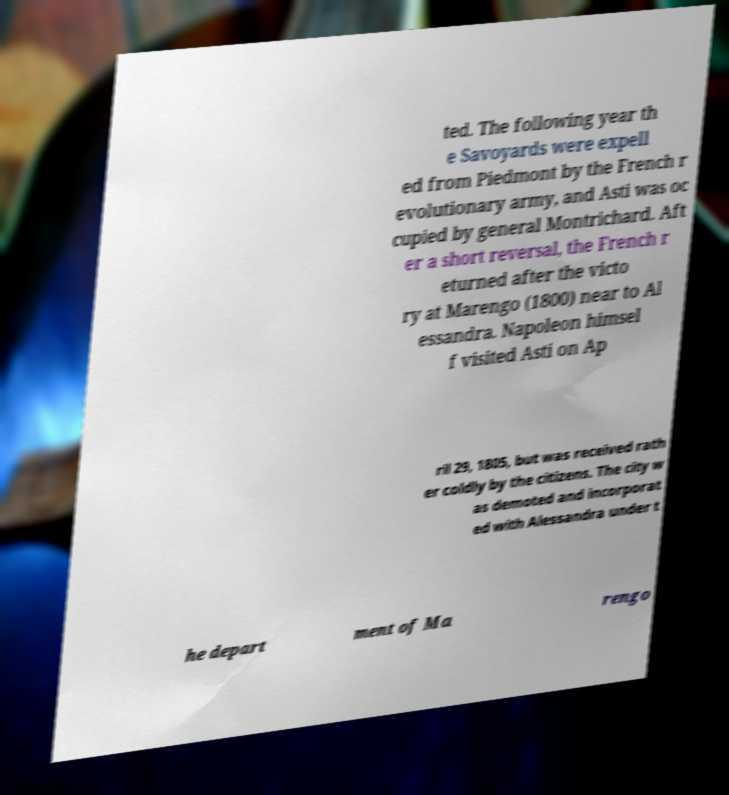Please identify and transcribe the text found in this image. ted. The following year th e Savoyards were expell ed from Piedmont by the French r evolutionary army, and Asti was oc cupied by general Montrichard. Aft er a short reversal, the French r eturned after the victo ry at Marengo (1800) near to Al essandra. Napoleon himsel f visited Asti on Ap ril 29, 1805, but was received rath er coldly by the citizens. The city w as demoted and incorporat ed with Alessandra under t he depart ment of Ma rengo 